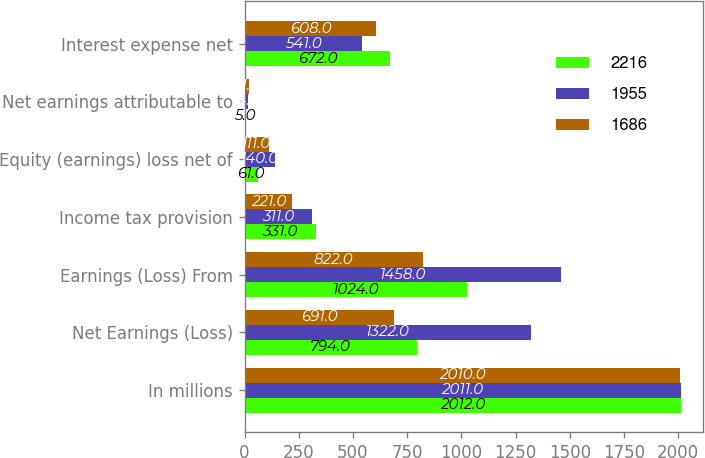<chart> <loc_0><loc_0><loc_500><loc_500><stacked_bar_chart><ecel><fcel>In millions<fcel>Net Earnings (Loss)<fcel>Earnings (Loss) From<fcel>Income tax provision<fcel>Equity (earnings) loss net of<fcel>Net earnings attributable to<fcel>Interest expense net<nl><fcel>2216<fcel>2012<fcel>794<fcel>1024<fcel>331<fcel>61<fcel>5<fcel>672<nl><fcel>1955<fcel>2011<fcel>1322<fcel>1458<fcel>311<fcel>140<fcel>14<fcel>541<nl><fcel>1686<fcel>2010<fcel>691<fcel>822<fcel>221<fcel>111<fcel>21<fcel>608<nl></chart> 